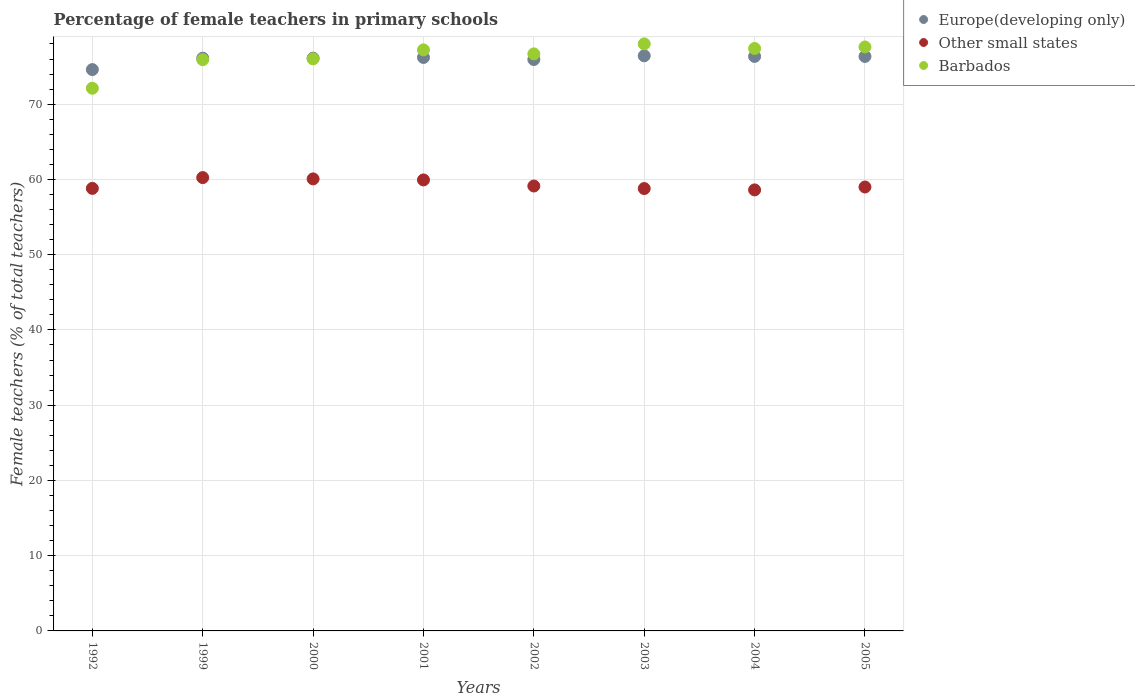What is the percentage of female teachers in Europe(developing only) in 2002?
Your answer should be compact. 75.94. Across all years, what is the maximum percentage of female teachers in Europe(developing only)?
Ensure brevity in your answer.  76.43. Across all years, what is the minimum percentage of female teachers in Other small states?
Your response must be concise. 58.61. In which year was the percentage of female teachers in Barbados maximum?
Your response must be concise. 2003. In which year was the percentage of female teachers in Barbados minimum?
Your response must be concise. 1992. What is the total percentage of female teachers in Europe(developing only) in the graph?
Provide a short and direct response. 608.1. What is the difference between the percentage of female teachers in Other small states in 2000 and that in 2003?
Your answer should be very brief. 1.28. What is the difference between the percentage of female teachers in Europe(developing only) in 1992 and the percentage of female teachers in Barbados in 2005?
Keep it short and to the point. -3.01. What is the average percentage of female teachers in Barbados per year?
Provide a short and direct response. 76.37. In the year 2003, what is the difference between the percentage of female teachers in Europe(developing only) and percentage of female teachers in Other small states?
Keep it short and to the point. 17.64. In how many years, is the percentage of female teachers in Other small states greater than 10 %?
Make the answer very short. 8. What is the ratio of the percentage of female teachers in Europe(developing only) in 2004 to that in 2005?
Your response must be concise. 1. Is the percentage of female teachers in Barbados in 2003 less than that in 2005?
Your response must be concise. No. Is the difference between the percentage of female teachers in Europe(developing only) in 2003 and 2004 greater than the difference between the percentage of female teachers in Other small states in 2003 and 2004?
Your response must be concise. No. What is the difference between the highest and the second highest percentage of female teachers in Barbados?
Ensure brevity in your answer.  0.41. What is the difference between the highest and the lowest percentage of female teachers in Europe(developing only)?
Provide a short and direct response. 1.83. Is the sum of the percentage of female teachers in Other small states in 1999 and 2001 greater than the maximum percentage of female teachers in Barbados across all years?
Give a very brief answer. Yes. Does the percentage of female teachers in Europe(developing only) monotonically increase over the years?
Keep it short and to the point. No. How many years are there in the graph?
Provide a succinct answer. 8. What is the difference between two consecutive major ticks on the Y-axis?
Your answer should be compact. 10. Are the values on the major ticks of Y-axis written in scientific E-notation?
Your answer should be very brief. No. Does the graph contain any zero values?
Ensure brevity in your answer.  No. Does the graph contain grids?
Offer a terse response. Yes. Where does the legend appear in the graph?
Offer a very short reply. Top right. How many legend labels are there?
Offer a terse response. 3. What is the title of the graph?
Keep it short and to the point. Percentage of female teachers in primary schools. Does "Bolivia" appear as one of the legend labels in the graph?
Provide a succinct answer. No. What is the label or title of the X-axis?
Provide a short and direct response. Years. What is the label or title of the Y-axis?
Provide a short and direct response. Female teachers (% of total teachers). What is the Female teachers (% of total teachers) of Europe(developing only) in 1992?
Your answer should be compact. 74.6. What is the Female teachers (% of total teachers) in Other small states in 1992?
Your response must be concise. 58.81. What is the Female teachers (% of total teachers) of Barbados in 1992?
Your answer should be very brief. 72.12. What is the Female teachers (% of total teachers) of Europe(developing only) in 1999?
Offer a very short reply. 76.11. What is the Female teachers (% of total teachers) in Other small states in 1999?
Make the answer very short. 60.24. What is the Female teachers (% of total teachers) of Barbados in 1999?
Your answer should be very brief. 75.91. What is the Female teachers (% of total teachers) in Europe(developing only) in 2000?
Give a very brief answer. 76.12. What is the Female teachers (% of total teachers) in Other small states in 2000?
Keep it short and to the point. 60.07. What is the Female teachers (% of total teachers) of Barbados in 2000?
Offer a terse response. 76.02. What is the Female teachers (% of total teachers) in Europe(developing only) in 2001?
Offer a terse response. 76.21. What is the Female teachers (% of total teachers) of Other small states in 2001?
Give a very brief answer. 59.93. What is the Female teachers (% of total teachers) in Barbados in 2001?
Provide a succinct answer. 77.22. What is the Female teachers (% of total teachers) of Europe(developing only) in 2002?
Ensure brevity in your answer.  75.94. What is the Female teachers (% of total teachers) in Other small states in 2002?
Provide a succinct answer. 59.12. What is the Female teachers (% of total teachers) of Barbados in 2002?
Give a very brief answer. 76.68. What is the Female teachers (% of total teachers) of Europe(developing only) in 2003?
Your answer should be compact. 76.43. What is the Female teachers (% of total teachers) of Other small states in 2003?
Your answer should be very brief. 58.79. What is the Female teachers (% of total teachers) of Barbados in 2003?
Keep it short and to the point. 78.01. What is the Female teachers (% of total teachers) in Europe(developing only) in 2004?
Your answer should be compact. 76.35. What is the Female teachers (% of total teachers) in Other small states in 2004?
Provide a succinct answer. 58.61. What is the Female teachers (% of total teachers) of Barbados in 2004?
Provide a succinct answer. 77.4. What is the Female teachers (% of total teachers) in Europe(developing only) in 2005?
Your answer should be compact. 76.34. What is the Female teachers (% of total teachers) of Other small states in 2005?
Your answer should be very brief. 58.99. What is the Female teachers (% of total teachers) of Barbados in 2005?
Make the answer very short. 77.6. Across all years, what is the maximum Female teachers (% of total teachers) of Europe(developing only)?
Provide a short and direct response. 76.43. Across all years, what is the maximum Female teachers (% of total teachers) in Other small states?
Make the answer very short. 60.24. Across all years, what is the maximum Female teachers (% of total teachers) in Barbados?
Offer a terse response. 78.01. Across all years, what is the minimum Female teachers (% of total teachers) of Europe(developing only)?
Make the answer very short. 74.6. Across all years, what is the minimum Female teachers (% of total teachers) of Other small states?
Provide a succinct answer. 58.61. Across all years, what is the minimum Female teachers (% of total teachers) in Barbados?
Your answer should be very brief. 72.12. What is the total Female teachers (% of total teachers) of Europe(developing only) in the graph?
Ensure brevity in your answer.  608.1. What is the total Female teachers (% of total teachers) of Other small states in the graph?
Ensure brevity in your answer.  474.57. What is the total Female teachers (% of total teachers) of Barbados in the graph?
Provide a short and direct response. 610.97. What is the difference between the Female teachers (% of total teachers) in Europe(developing only) in 1992 and that in 1999?
Give a very brief answer. -1.52. What is the difference between the Female teachers (% of total teachers) of Other small states in 1992 and that in 1999?
Provide a short and direct response. -1.44. What is the difference between the Female teachers (% of total teachers) in Barbados in 1992 and that in 1999?
Your answer should be compact. -3.8. What is the difference between the Female teachers (% of total teachers) of Europe(developing only) in 1992 and that in 2000?
Your answer should be very brief. -1.52. What is the difference between the Female teachers (% of total teachers) in Other small states in 1992 and that in 2000?
Offer a terse response. -1.26. What is the difference between the Female teachers (% of total teachers) of Barbados in 1992 and that in 2000?
Provide a short and direct response. -3.9. What is the difference between the Female teachers (% of total teachers) in Europe(developing only) in 1992 and that in 2001?
Your response must be concise. -1.61. What is the difference between the Female teachers (% of total teachers) of Other small states in 1992 and that in 2001?
Ensure brevity in your answer.  -1.12. What is the difference between the Female teachers (% of total teachers) in Barbados in 1992 and that in 2001?
Provide a short and direct response. -5.1. What is the difference between the Female teachers (% of total teachers) in Europe(developing only) in 1992 and that in 2002?
Give a very brief answer. -1.34. What is the difference between the Female teachers (% of total teachers) in Other small states in 1992 and that in 2002?
Ensure brevity in your answer.  -0.32. What is the difference between the Female teachers (% of total teachers) in Barbados in 1992 and that in 2002?
Provide a succinct answer. -4.56. What is the difference between the Female teachers (% of total teachers) in Europe(developing only) in 1992 and that in 2003?
Give a very brief answer. -1.83. What is the difference between the Female teachers (% of total teachers) in Other small states in 1992 and that in 2003?
Offer a very short reply. 0.02. What is the difference between the Female teachers (% of total teachers) of Barbados in 1992 and that in 2003?
Give a very brief answer. -5.9. What is the difference between the Female teachers (% of total teachers) in Europe(developing only) in 1992 and that in 2004?
Keep it short and to the point. -1.75. What is the difference between the Female teachers (% of total teachers) of Other small states in 1992 and that in 2004?
Your response must be concise. 0.2. What is the difference between the Female teachers (% of total teachers) in Barbados in 1992 and that in 2004?
Provide a short and direct response. -5.28. What is the difference between the Female teachers (% of total teachers) of Europe(developing only) in 1992 and that in 2005?
Offer a terse response. -1.75. What is the difference between the Female teachers (% of total teachers) of Other small states in 1992 and that in 2005?
Provide a short and direct response. -0.18. What is the difference between the Female teachers (% of total teachers) of Barbados in 1992 and that in 2005?
Provide a short and direct response. -5.49. What is the difference between the Female teachers (% of total teachers) of Europe(developing only) in 1999 and that in 2000?
Give a very brief answer. -0.01. What is the difference between the Female teachers (% of total teachers) in Other small states in 1999 and that in 2000?
Provide a succinct answer. 0.17. What is the difference between the Female teachers (% of total teachers) of Barbados in 1999 and that in 2000?
Give a very brief answer. -0.11. What is the difference between the Female teachers (% of total teachers) in Europe(developing only) in 1999 and that in 2001?
Provide a succinct answer. -0.1. What is the difference between the Female teachers (% of total teachers) in Other small states in 1999 and that in 2001?
Your answer should be very brief. 0.31. What is the difference between the Female teachers (% of total teachers) of Barbados in 1999 and that in 2001?
Provide a short and direct response. -1.3. What is the difference between the Female teachers (% of total teachers) of Europe(developing only) in 1999 and that in 2002?
Make the answer very short. 0.17. What is the difference between the Female teachers (% of total teachers) in Other small states in 1999 and that in 2002?
Provide a succinct answer. 1.12. What is the difference between the Female teachers (% of total teachers) of Barbados in 1999 and that in 2002?
Your response must be concise. -0.77. What is the difference between the Female teachers (% of total teachers) in Europe(developing only) in 1999 and that in 2003?
Your response must be concise. -0.32. What is the difference between the Female teachers (% of total teachers) of Other small states in 1999 and that in 2003?
Your answer should be very brief. 1.46. What is the difference between the Female teachers (% of total teachers) in Barbados in 1999 and that in 2003?
Your answer should be compact. -2.1. What is the difference between the Female teachers (% of total teachers) in Europe(developing only) in 1999 and that in 2004?
Give a very brief answer. -0.23. What is the difference between the Female teachers (% of total teachers) of Other small states in 1999 and that in 2004?
Your answer should be very brief. 1.64. What is the difference between the Female teachers (% of total teachers) in Barbados in 1999 and that in 2004?
Provide a succinct answer. -1.49. What is the difference between the Female teachers (% of total teachers) of Europe(developing only) in 1999 and that in 2005?
Keep it short and to the point. -0.23. What is the difference between the Female teachers (% of total teachers) in Other small states in 1999 and that in 2005?
Provide a succinct answer. 1.25. What is the difference between the Female teachers (% of total teachers) of Barbados in 1999 and that in 2005?
Make the answer very short. -1.69. What is the difference between the Female teachers (% of total teachers) in Europe(developing only) in 2000 and that in 2001?
Ensure brevity in your answer.  -0.09. What is the difference between the Female teachers (% of total teachers) of Other small states in 2000 and that in 2001?
Keep it short and to the point. 0.14. What is the difference between the Female teachers (% of total teachers) in Barbados in 2000 and that in 2001?
Ensure brevity in your answer.  -1.19. What is the difference between the Female teachers (% of total teachers) of Europe(developing only) in 2000 and that in 2002?
Make the answer very short. 0.18. What is the difference between the Female teachers (% of total teachers) of Other small states in 2000 and that in 2002?
Provide a succinct answer. 0.95. What is the difference between the Female teachers (% of total teachers) of Barbados in 2000 and that in 2002?
Provide a succinct answer. -0.66. What is the difference between the Female teachers (% of total teachers) in Europe(developing only) in 2000 and that in 2003?
Your answer should be very brief. -0.31. What is the difference between the Female teachers (% of total teachers) of Other small states in 2000 and that in 2003?
Keep it short and to the point. 1.28. What is the difference between the Female teachers (% of total teachers) of Barbados in 2000 and that in 2003?
Make the answer very short. -1.99. What is the difference between the Female teachers (% of total teachers) of Europe(developing only) in 2000 and that in 2004?
Your response must be concise. -0.23. What is the difference between the Female teachers (% of total teachers) of Other small states in 2000 and that in 2004?
Give a very brief answer. 1.46. What is the difference between the Female teachers (% of total teachers) of Barbados in 2000 and that in 2004?
Ensure brevity in your answer.  -1.38. What is the difference between the Female teachers (% of total teachers) in Europe(developing only) in 2000 and that in 2005?
Make the answer very short. -0.23. What is the difference between the Female teachers (% of total teachers) in Other small states in 2000 and that in 2005?
Your answer should be very brief. 1.08. What is the difference between the Female teachers (% of total teachers) of Barbados in 2000 and that in 2005?
Your answer should be very brief. -1.58. What is the difference between the Female teachers (% of total teachers) in Europe(developing only) in 2001 and that in 2002?
Ensure brevity in your answer.  0.27. What is the difference between the Female teachers (% of total teachers) of Other small states in 2001 and that in 2002?
Offer a terse response. 0.81. What is the difference between the Female teachers (% of total teachers) in Barbados in 2001 and that in 2002?
Offer a terse response. 0.53. What is the difference between the Female teachers (% of total teachers) in Europe(developing only) in 2001 and that in 2003?
Offer a terse response. -0.22. What is the difference between the Female teachers (% of total teachers) in Other small states in 2001 and that in 2003?
Keep it short and to the point. 1.15. What is the difference between the Female teachers (% of total teachers) of Barbados in 2001 and that in 2003?
Your answer should be compact. -0.8. What is the difference between the Female teachers (% of total teachers) in Europe(developing only) in 2001 and that in 2004?
Provide a succinct answer. -0.14. What is the difference between the Female teachers (% of total teachers) in Other small states in 2001 and that in 2004?
Give a very brief answer. 1.33. What is the difference between the Female teachers (% of total teachers) of Barbados in 2001 and that in 2004?
Keep it short and to the point. -0.19. What is the difference between the Female teachers (% of total teachers) of Europe(developing only) in 2001 and that in 2005?
Offer a very short reply. -0.14. What is the difference between the Female teachers (% of total teachers) in Other small states in 2001 and that in 2005?
Give a very brief answer. 0.94. What is the difference between the Female teachers (% of total teachers) of Barbados in 2001 and that in 2005?
Provide a succinct answer. -0.39. What is the difference between the Female teachers (% of total teachers) in Europe(developing only) in 2002 and that in 2003?
Make the answer very short. -0.49. What is the difference between the Female teachers (% of total teachers) in Other small states in 2002 and that in 2003?
Provide a succinct answer. 0.34. What is the difference between the Female teachers (% of total teachers) in Barbados in 2002 and that in 2003?
Keep it short and to the point. -1.33. What is the difference between the Female teachers (% of total teachers) in Europe(developing only) in 2002 and that in 2004?
Keep it short and to the point. -0.41. What is the difference between the Female teachers (% of total teachers) in Other small states in 2002 and that in 2004?
Provide a succinct answer. 0.52. What is the difference between the Female teachers (% of total teachers) in Barbados in 2002 and that in 2004?
Give a very brief answer. -0.72. What is the difference between the Female teachers (% of total teachers) of Europe(developing only) in 2002 and that in 2005?
Your answer should be compact. -0.41. What is the difference between the Female teachers (% of total teachers) in Other small states in 2002 and that in 2005?
Provide a short and direct response. 0.13. What is the difference between the Female teachers (% of total teachers) of Barbados in 2002 and that in 2005?
Your answer should be very brief. -0.92. What is the difference between the Female teachers (% of total teachers) in Europe(developing only) in 2003 and that in 2004?
Ensure brevity in your answer.  0.09. What is the difference between the Female teachers (% of total teachers) in Other small states in 2003 and that in 2004?
Your response must be concise. 0.18. What is the difference between the Female teachers (% of total teachers) in Barbados in 2003 and that in 2004?
Offer a terse response. 0.61. What is the difference between the Female teachers (% of total teachers) of Europe(developing only) in 2003 and that in 2005?
Keep it short and to the point. 0.09. What is the difference between the Female teachers (% of total teachers) in Other small states in 2003 and that in 2005?
Provide a succinct answer. -0.2. What is the difference between the Female teachers (% of total teachers) of Barbados in 2003 and that in 2005?
Your answer should be very brief. 0.41. What is the difference between the Female teachers (% of total teachers) of Europe(developing only) in 2004 and that in 2005?
Offer a terse response. 0. What is the difference between the Female teachers (% of total teachers) in Other small states in 2004 and that in 2005?
Your response must be concise. -0.39. What is the difference between the Female teachers (% of total teachers) of Barbados in 2004 and that in 2005?
Provide a short and direct response. -0.2. What is the difference between the Female teachers (% of total teachers) of Europe(developing only) in 1992 and the Female teachers (% of total teachers) of Other small states in 1999?
Your response must be concise. 14.35. What is the difference between the Female teachers (% of total teachers) in Europe(developing only) in 1992 and the Female teachers (% of total teachers) in Barbados in 1999?
Your response must be concise. -1.32. What is the difference between the Female teachers (% of total teachers) in Other small states in 1992 and the Female teachers (% of total teachers) in Barbados in 1999?
Provide a short and direct response. -17.1. What is the difference between the Female teachers (% of total teachers) in Europe(developing only) in 1992 and the Female teachers (% of total teachers) in Other small states in 2000?
Your answer should be very brief. 14.53. What is the difference between the Female teachers (% of total teachers) of Europe(developing only) in 1992 and the Female teachers (% of total teachers) of Barbados in 2000?
Give a very brief answer. -1.43. What is the difference between the Female teachers (% of total teachers) of Other small states in 1992 and the Female teachers (% of total teachers) of Barbados in 2000?
Make the answer very short. -17.21. What is the difference between the Female teachers (% of total teachers) in Europe(developing only) in 1992 and the Female teachers (% of total teachers) in Other small states in 2001?
Ensure brevity in your answer.  14.66. What is the difference between the Female teachers (% of total teachers) of Europe(developing only) in 1992 and the Female teachers (% of total teachers) of Barbados in 2001?
Make the answer very short. -2.62. What is the difference between the Female teachers (% of total teachers) in Other small states in 1992 and the Female teachers (% of total teachers) in Barbados in 2001?
Your response must be concise. -18.41. What is the difference between the Female teachers (% of total teachers) of Europe(developing only) in 1992 and the Female teachers (% of total teachers) of Other small states in 2002?
Make the answer very short. 15.47. What is the difference between the Female teachers (% of total teachers) of Europe(developing only) in 1992 and the Female teachers (% of total teachers) of Barbados in 2002?
Make the answer very short. -2.09. What is the difference between the Female teachers (% of total teachers) of Other small states in 1992 and the Female teachers (% of total teachers) of Barbados in 2002?
Ensure brevity in your answer.  -17.87. What is the difference between the Female teachers (% of total teachers) of Europe(developing only) in 1992 and the Female teachers (% of total teachers) of Other small states in 2003?
Keep it short and to the point. 15.81. What is the difference between the Female teachers (% of total teachers) of Europe(developing only) in 1992 and the Female teachers (% of total teachers) of Barbados in 2003?
Keep it short and to the point. -3.42. What is the difference between the Female teachers (% of total teachers) of Other small states in 1992 and the Female teachers (% of total teachers) of Barbados in 2003?
Provide a succinct answer. -19.2. What is the difference between the Female teachers (% of total teachers) in Europe(developing only) in 1992 and the Female teachers (% of total teachers) in Other small states in 2004?
Offer a very short reply. 15.99. What is the difference between the Female teachers (% of total teachers) in Europe(developing only) in 1992 and the Female teachers (% of total teachers) in Barbados in 2004?
Ensure brevity in your answer.  -2.8. What is the difference between the Female teachers (% of total teachers) in Other small states in 1992 and the Female teachers (% of total teachers) in Barbados in 2004?
Provide a short and direct response. -18.59. What is the difference between the Female teachers (% of total teachers) of Europe(developing only) in 1992 and the Female teachers (% of total teachers) of Other small states in 2005?
Ensure brevity in your answer.  15.6. What is the difference between the Female teachers (% of total teachers) in Europe(developing only) in 1992 and the Female teachers (% of total teachers) in Barbados in 2005?
Provide a short and direct response. -3.01. What is the difference between the Female teachers (% of total teachers) in Other small states in 1992 and the Female teachers (% of total teachers) in Barbados in 2005?
Give a very brief answer. -18.79. What is the difference between the Female teachers (% of total teachers) in Europe(developing only) in 1999 and the Female teachers (% of total teachers) in Other small states in 2000?
Your answer should be compact. 16.04. What is the difference between the Female teachers (% of total teachers) in Europe(developing only) in 1999 and the Female teachers (% of total teachers) in Barbados in 2000?
Your answer should be very brief. 0.09. What is the difference between the Female teachers (% of total teachers) in Other small states in 1999 and the Female teachers (% of total teachers) in Barbados in 2000?
Your answer should be compact. -15.78. What is the difference between the Female teachers (% of total teachers) of Europe(developing only) in 1999 and the Female teachers (% of total teachers) of Other small states in 2001?
Give a very brief answer. 16.18. What is the difference between the Female teachers (% of total teachers) in Europe(developing only) in 1999 and the Female teachers (% of total teachers) in Barbados in 2001?
Keep it short and to the point. -1.1. What is the difference between the Female teachers (% of total teachers) of Other small states in 1999 and the Female teachers (% of total teachers) of Barbados in 2001?
Provide a succinct answer. -16.97. What is the difference between the Female teachers (% of total teachers) in Europe(developing only) in 1999 and the Female teachers (% of total teachers) in Other small states in 2002?
Provide a succinct answer. 16.99. What is the difference between the Female teachers (% of total teachers) of Europe(developing only) in 1999 and the Female teachers (% of total teachers) of Barbados in 2002?
Ensure brevity in your answer.  -0.57. What is the difference between the Female teachers (% of total teachers) of Other small states in 1999 and the Female teachers (% of total teachers) of Barbados in 2002?
Offer a very short reply. -16.44. What is the difference between the Female teachers (% of total teachers) in Europe(developing only) in 1999 and the Female teachers (% of total teachers) in Other small states in 2003?
Provide a short and direct response. 17.32. What is the difference between the Female teachers (% of total teachers) in Europe(developing only) in 1999 and the Female teachers (% of total teachers) in Barbados in 2003?
Ensure brevity in your answer.  -1.9. What is the difference between the Female teachers (% of total teachers) in Other small states in 1999 and the Female teachers (% of total teachers) in Barbados in 2003?
Ensure brevity in your answer.  -17.77. What is the difference between the Female teachers (% of total teachers) in Europe(developing only) in 1999 and the Female teachers (% of total teachers) in Other small states in 2004?
Offer a terse response. 17.5. What is the difference between the Female teachers (% of total teachers) of Europe(developing only) in 1999 and the Female teachers (% of total teachers) of Barbados in 2004?
Give a very brief answer. -1.29. What is the difference between the Female teachers (% of total teachers) of Other small states in 1999 and the Female teachers (% of total teachers) of Barbados in 2004?
Your answer should be compact. -17.16. What is the difference between the Female teachers (% of total teachers) in Europe(developing only) in 1999 and the Female teachers (% of total teachers) in Other small states in 2005?
Offer a terse response. 17.12. What is the difference between the Female teachers (% of total teachers) of Europe(developing only) in 1999 and the Female teachers (% of total teachers) of Barbados in 2005?
Offer a very short reply. -1.49. What is the difference between the Female teachers (% of total teachers) of Other small states in 1999 and the Female teachers (% of total teachers) of Barbados in 2005?
Offer a very short reply. -17.36. What is the difference between the Female teachers (% of total teachers) in Europe(developing only) in 2000 and the Female teachers (% of total teachers) in Other small states in 2001?
Your answer should be very brief. 16.18. What is the difference between the Female teachers (% of total teachers) in Europe(developing only) in 2000 and the Female teachers (% of total teachers) in Barbados in 2001?
Give a very brief answer. -1.1. What is the difference between the Female teachers (% of total teachers) in Other small states in 2000 and the Female teachers (% of total teachers) in Barbados in 2001?
Provide a short and direct response. -17.14. What is the difference between the Female teachers (% of total teachers) of Europe(developing only) in 2000 and the Female teachers (% of total teachers) of Other small states in 2002?
Your response must be concise. 16.99. What is the difference between the Female teachers (% of total teachers) in Europe(developing only) in 2000 and the Female teachers (% of total teachers) in Barbados in 2002?
Give a very brief answer. -0.56. What is the difference between the Female teachers (% of total teachers) of Other small states in 2000 and the Female teachers (% of total teachers) of Barbados in 2002?
Your answer should be compact. -16.61. What is the difference between the Female teachers (% of total teachers) in Europe(developing only) in 2000 and the Female teachers (% of total teachers) in Other small states in 2003?
Your response must be concise. 17.33. What is the difference between the Female teachers (% of total teachers) in Europe(developing only) in 2000 and the Female teachers (% of total teachers) in Barbados in 2003?
Make the answer very short. -1.9. What is the difference between the Female teachers (% of total teachers) of Other small states in 2000 and the Female teachers (% of total teachers) of Barbados in 2003?
Offer a terse response. -17.94. What is the difference between the Female teachers (% of total teachers) in Europe(developing only) in 2000 and the Female teachers (% of total teachers) in Other small states in 2004?
Your answer should be very brief. 17.51. What is the difference between the Female teachers (% of total teachers) in Europe(developing only) in 2000 and the Female teachers (% of total teachers) in Barbados in 2004?
Your response must be concise. -1.28. What is the difference between the Female teachers (% of total teachers) in Other small states in 2000 and the Female teachers (% of total teachers) in Barbados in 2004?
Keep it short and to the point. -17.33. What is the difference between the Female teachers (% of total teachers) of Europe(developing only) in 2000 and the Female teachers (% of total teachers) of Other small states in 2005?
Provide a succinct answer. 17.13. What is the difference between the Female teachers (% of total teachers) of Europe(developing only) in 2000 and the Female teachers (% of total teachers) of Barbados in 2005?
Make the answer very short. -1.49. What is the difference between the Female teachers (% of total teachers) in Other small states in 2000 and the Female teachers (% of total teachers) in Barbados in 2005?
Your answer should be compact. -17.53. What is the difference between the Female teachers (% of total teachers) of Europe(developing only) in 2001 and the Female teachers (% of total teachers) of Other small states in 2002?
Keep it short and to the point. 17.08. What is the difference between the Female teachers (% of total teachers) of Europe(developing only) in 2001 and the Female teachers (% of total teachers) of Barbados in 2002?
Ensure brevity in your answer.  -0.47. What is the difference between the Female teachers (% of total teachers) of Other small states in 2001 and the Female teachers (% of total teachers) of Barbados in 2002?
Ensure brevity in your answer.  -16.75. What is the difference between the Female teachers (% of total teachers) in Europe(developing only) in 2001 and the Female teachers (% of total teachers) in Other small states in 2003?
Keep it short and to the point. 17.42. What is the difference between the Female teachers (% of total teachers) of Europe(developing only) in 2001 and the Female teachers (% of total teachers) of Barbados in 2003?
Offer a very short reply. -1.81. What is the difference between the Female teachers (% of total teachers) of Other small states in 2001 and the Female teachers (% of total teachers) of Barbados in 2003?
Offer a terse response. -18.08. What is the difference between the Female teachers (% of total teachers) of Europe(developing only) in 2001 and the Female teachers (% of total teachers) of Other small states in 2004?
Give a very brief answer. 17.6. What is the difference between the Female teachers (% of total teachers) of Europe(developing only) in 2001 and the Female teachers (% of total teachers) of Barbados in 2004?
Ensure brevity in your answer.  -1.19. What is the difference between the Female teachers (% of total teachers) in Other small states in 2001 and the Female teachers (% of total teachers) in Barbados in 2004?
Make the answer very short. -17.47. What is the difference between the Female teachers (% of total teachers) of Europe(developing only) in 2001 and the Female teachers (% of total teachers) of Other small states in 2005?
Provide a succinct answer. 17.22. What is the difference between the Female teachers (% of total teachers) of Europe(developing only) in 2001 and the Female teachers (% of total teachers) of Barbados in 2005?
Your response must be concise. -1.4. What is the difference between the Female teachers (% of total teachers) of Other small states in 2001 and the Female teachers (% of total teachers) of Barbados in 2005?
Your answer should be compact. -17.67. What is the difference between the Female teachers (% of total teachers) of Europe(developing only) in 2002 and the Female teachers (% of total teachers) of Other small states in 2003?
Make the answer very short. 17.15. What is the difference between the Female teachers (% of total teachers) of Europe(developing only) in 2002 and the Female teachers (% of total teachers) of Barbados in 2003?
Your answer should be very brief. -2.07. What is the difference between the Female teachers (% of total teachers) in Other small states in 2002 and the Female teachers (% of total teachers) in Barbados in 2003?
Offer a very short reply. -18.89. What is the difference between the Female teachers (% of total teachers) of Europe(developing only) in 2002 and the Female teachers (% of total teachers) of Other small states in 2004?
Your response must be concise. 17.33. What is the difference between the Female teachers (% of total teachers) of Europe(developing only) in 2002 and the Female teachers (% of total teachers) of Barbados in 2004?
Offer a very short reply. -1.46. What is the difference between the Female teachers (% of total teachers) in Other small states in 2002 and the Female teachers (% of total teachers) in Barbados in 2004?
Provide a short and direct response. -18.28. What is the difference between the Female teachers (% of total teachers) in Europe(developing only) in 2002 and the Female teachers (% of total teachers) in Other small states in 2005?
Provide a succinct answer. 16.95. What is the difference between the Female teachers (% of total teachers) of Europe(developing only) in 2002 and the Female teachers (% of total teachers) of Barbados in 2005?
Provide a succinct answer. -1.66. What is the difference between the Female teachers (% of total teachers) of Other small states in 2002 and the Female teachers (% of total teachers) of Barbados in 2005?
Your answer should be compact. -18.48. What is the difference between the Female teachers (% of total teachers) in Europe(developing only) in 2003 and the Female teachers (% of total teachers) in Other small states in 2004?
Offer a terse response. 17.82. What is the difference between the Female teachers (% of total teachers) in Europe(developing only) in 2003 and the Female teachers (% of total teachers) in Barbados in 2004?
Provide a succinct answer. -0.97. What is the difference between the Female teachers (% of total teachers) of Other small states in 2003 and the Female teachers (% of total teachers) of Barbados in 2004?
Your answer should be compact. -18.61. What is the difference between the Female teachers (% of total teachers) of Europe(developing only) in 2003 and the Female teachers (% of total teachers) of Other small states in 2005?
Your response must be concise. 17.44. What is the difference between the Female teachers (% of total teachers) in Europe(developing only) in 2003 and the Female teachers (% of total teachers) in Barbados in 2005?
Offer a very short reply. -1.17. What is the difference between the Female teachers (% of total teachers) of Other small states in 2003 and the Female teachers (% of total teachers) of Barbados in 2005?
Give a very brief answer. -18.82. What is the difference between the Female teachers (% of total teachers) in Europe(developing only) in 2004 and the Female teachers (% of total teachers) in Other small states in 2005?
Ensure brevity in your answer.  17.35. What is the difference between the Female teachers (% of total teachers) of Europe(developing only) in 2004 and the Female teachers (% of total teachers) of Barbados in 2005?
Offer a very short reply. -1.26. What is the difference between the Female teachers (% of total teachers) in Other small states in 2004 and the Female teachers (% of total teachers) in Barbados in 2005?
Provide a short and direct response. -19. What is the average Female teachers (% of total teachers) in Europe(developing only) per year?
Give a very brief answer. 76.01. What is the average Female teachers (% of total teachers) in Other small states per year?
Keep it short and to the point. 59.32. What is the average Female teachers (% of total teachers) in Barbados per year?
Your answer should be very brief. 76.37. In the year 1992, what is the difference between the Female teachers (% of total teachers) of Europe(developing only) and Female teachers (% of total teachers) of Other small states?
Your answer should be compact. 15.79. In the year 1992, what is the difference between the Female teachers (% of total teachers) in Europe(developing only) and Female teachers (% of total teachers) in Barbados?
Make the answer very short. 2.48. In the year 1992, what is the difference between the Female teachers (% of total teachers) in Other small states and Female teachers (% of total teachers) in Barbados?
Your response must be concise. -13.31. In the year 1999, what is the difference between the Female teachers (% of total teachers) in Europe(developing only) and Female teachers (% of total teachers) in Other small states?
Provide a short and direct response. 15.87. In the year 1999, what is the difference between the Female teachers (% of total teachers) in Europe(developing only) and Female teachers (% of total teachers) in Barbados?
Provide a short and direct response. 0.2. In the year 1999, what is the difference between the Female teachers (% of total teachers) in Other small states and Female teachers (% of total teachers) in Barbados?
Your response must be concise. -15.67. In the year 2000, what is the difference between the Female teachers (% of total teachers) in Europe(developing only) and Female teachers (% of total teachers) in Other small states?
Offer a very short reply. 16.05. In the year 2000, what is the difference between the Female teachers (% of total teachers) of Europe(developing only) and Female teachers (% of total teachers) of Barbados?
Your response must be concise. 0.09. In the year 2000, what is the difference between the Female teachers (% of total teachers) of Other small states and Female teachers (% of total teachers) of Barbados?
Ensure brevity in your answer.  -15.95. In the year 2001, what is the difference between the Female teachers (% of total teachers) in Europe(developing only) and Female teachers (% of total teachers) in Other small states?
Make the answer very short. 16.27. In the year 2001, what is the difference between the Female teachers (% of total teachers) in Europe(developing only) and Female teachers (% of total teachers) in Barbados?
Offer a terse response. -1.01. In the year 2001, what is the difference between the Female teachers (% of total teachers) of Other small states and Female teachers (% of total teachers) of Barbados?
Offer a very short reply. -17.28. In the year 2002, what is the difference between the Female teachers (% of total teachers) in Europe(developing only) and Female teachers (% of total teachers) in Other small states?
Your response must be concise. 16.81. In the year 2002, what is the difference between the Female teachers (% of total teachers) in Europe(developing only) and Female teachers (% of total teachers) in Barbados?
Give a very brief answer. -0.74. In the year 2002, what is the difference between the Female teachers (% of total teachers) of Other small states and Female teachers (% of total teachers) of Barbados?
Ensure brevity in your answer.  -17.56. In the year 2003, what is the difference between the Female teachers (% of total teachers) of Europe(developing only) and Female teachers (% of total teachers) of Other small states?
Your answer should be compact. 17.64. In the year 2003, what is the difference between the Female teachers (% of total teachers) of Europe(developing only) and Female teachers (% of total teachers) of Barbados?
Your answer should be very brief. -1.58. In the year 2003, what is the difference between the Female teachers (% of total teachers) in Other small states and Female teachers (% of total teachers) in Barbados?
Offer a very short reply. -19.23. In the year 2004, what is the difference between the Female teachers (% of total teachers) of Europe(developing only) and Female teachers (% of total teachers) of Other small states?
Offer a terse response. 17.74. In the year 2004, what is the difference between the Female teachers (% of total teachers) of Europe(developing only) and Female teachers (% of total teachers) of Barbados?
Provide a succinct answer. -1.05. In the year 2004, what is the difference between the Female teachers (% of total teachers) in Other small states and Female teachers (% of total teachers) in Barbados?
Provide a short and direct response. -18.79. In the year 2005, what is the difference between the Female teachers (% of total teachers) of Europe(developing only) and Female teachers (% of total teachers) of Other small states?
Offer a very short reply. 17.35. In the year 2005, what is the difference between the Female teachers (% of total teachers) in Europe(developing only) and Female teachers (% of total teachers) in Barbados?
Offer a very short reply. -1.26. In the year 2005, what is the difference between the Female teachers (% of total teachers) in Other small states and Female teachers (% of total teachers) in Barbados?
Offer a very short reply. -18.61. What is the ratio of the Female teachers (% of total teachers) of Europe(developing only) in 1992 to that in 1999?
Ensure brevity in your answer.  0.98. What is the ratio of the Female teachers (% of total teachers) of Other small states in 1992 to that in 1999?
Provide a short and direct response. 0.98. What is the ratio of the Female teachers (% of total teachers) of Europe(developing only) in 1992 to that in 2000?
Your response must be concise. 0.98. What is the ratio of the Female teachers (% of total teachers) of Barbados in 1992 to that in 2000?
Keep it short and to the point. 0.95. What is the ratio of the Female teachers (% of total teachers) in Europe(developing only) in 1992 to that in 2001?
Provide a succinct answer. 0.98. What is the ratio of the Female teachers (% of total teachers) in Other small states in 1992 to that in 2001?
Offer a very short reply. 0.98. What is the ratio of the Female teachers (% of total teachers) in Barbados in 1992 to that in 2001?
Give a very brief answer. 0.93. What is the ratio of the Female teachers (% of total teachers) in Europe(developing only) in 1992 to that in 2002?
Your answer should be very brief. 0.98. What is the ratio of the Female teachers (% of total teachers) in Barbados in 1992 to that in 2002?
Provide a succinct answer. 0.94. What is the ratio of the Female teachers (% of total teachers) in Other small states in 1992 to that in 2003?
Your response must be concise. 1. What is the ratio of the Female teachers (% of total teachers) in Barbados in 1992 to that in 2003?
Provide a succinct answer. 0.92. What is the ratio of the Female teachers (% of total teachers) of Europe(developing only) in 1992 to that in 2004?
Provide a short and direct response. 0.98. What is the ratio of the Female teachers (% of total teachers) of Barbados in 1992 to that in 2004?
Offer a terse response. 0.93. What is the ratio of the Female teachers (% of total teachers) of Europe(developing only) in 1992 to that in 2005?
Your answer should be compact. 0.98. What is the ratio of the Female teachers (% of total teachers) of Barbados in 1992 to that in 2005?
Your answer should be very brief. 0.93. What is the ratio of the Female teachers (% of total teachers) in Europe(developing only) in 1999 to that in 2000?
Your answer should be very brief. 1. What is the ratio of the Female teachers (% of total teachers) in Other small states in 1999 to that in 2000?
Ensure brevity in your answer.  1. What is the ratio of the Female teachers (% of total teachers) in Barbados in 1999 to that in 2000?
Your answer should be very brief. 1. What is the ratio of the Female teachers (% of total teachers) of Other small states in 1999 to that in 2001?
Offer a very short reply. 1.01. What is the ratio of the Female teachers (% of total teachers) in Barbados in 1999 to that in 2001?
Your response must be concise. 0.98. What is the ratio of the Female teachers (% of total teachers) in Europe(developing only) in 1999 to that in 2002?
Offer a terse response. 1. What is the ratio of the Female teachers (% of total teachers) in Other small states in 1999 to that in 2002?
Your answer should be compact. 1.02. What is the ratio of the Female teachers (% of total teachers) in Europe(developing only) in 1999 to that in 2003?
Make the answer very short. 1. What is the ratio of the Female teachers (% of total teachers) in Other small states in 1999 to that in 2003?
Offer a terse response. 1.02. What is the ratio of the Female teachers (% of total teachers) of Barbados in 1999 to that in 2003?
Your answer should be very brief. 0.97. What is the ratio of the Female teachers (% of total teachers) in Europe(developing only) in 1999 to that in 2004?
Provide a short and direct response. 1. What is the ratio of the Female teachers (% of total teachers) in Other small states in 1999 to that in 2004?
Give a very brief answer. 1.03. What is the ratio of the Female teachers (% of total teachers) in Barbados in 1999 to that in 2004?
Give a very brief answer. 0.98. What is the ratio of the Female teachers (% of total teachers) of Europe(developing only) in 1999 to that in 2005?
Offer a terse response. 1. What is the ratio of the Female teachers (% of total teachers) of Other small states in 1999 to that in 2005?
Keep it short and to the point. 1.02. What is the ratio of the Female teachers (% of total teachers) in Barbados in 1999 to that in 2005?
Your answer should be very brief. 0.98. What is the ratio of the Female teachers (% of total teachers) in Other small states in 2000 to that in 2001?
Offer a terse response. 1. What is the ratio of the Female teachers (% of total teachers) in Barbados in 2000 to that in 2001?
Keep it short and to the point. 0.98. What is the ratio of the Female teachers (% of total teachers) in Other small states in 2000 to that in 2002?
Give a very brief answer. 1.02. What is the ratio of the Female teachers (% of total teachers) in Barbados in 2000 to that in 2002?
Ensure brevity in your answer.  0.99. What is the ratio of the Female teachers (% of total teachers) of Europe(developing only) in 2000 to that in 2003?
Your answer should be very brief. 1. What is the ratio of the Female teachers (% of total teachers) in Other small states in 2000 to that in 2003?
Your answer should be very brief. 1.02. What is the ratio of the Female teachers (% of total teachers) in Barbados in 2000 to that in 2003?
Ensure brevity in your answer.  0.97. What is the ratio of the Female teachers (% of total teachers) of Europe(developing only) in 2000 to that in 2004?
Your answer should be very brief. 1. What is the ratio of the Female teachers (% of total teachers) of Barbados in 2000 to that in 2004?
Give a very brief answer. 0.98. What is the ratio of the Female teachers (% of total teachers) in Europe(developing only) in 2000 to that in 2005?
Keep it short and to the point. 1. What is the ratio of the Female teachers (% of total teachers) of Other small states in 2000 to that in 2005?
Your answer should be compact. 1.02. What is the ratio of the Female teachers (% of total teachers) in Barbados in 2000 to that in 2005?
Keep it short and to the point. 0.98. What is the ratio of the Female teachers (% of total teachers) in Other small states in 2001 to that in 2002?
Your answer should be very brief. 1.01. What is the ratio of the Female teachers (% of total teachers) of Barbados in 2001 to that in 2002?
Offer a terse response. 1.01. What is the ratio of the Female teachers (% of total teachers) in Other small states in 2001 to that in 2003?
Offer a terse response. 1.02. What is the ratio of the Female teachers (% of total teachers) in Other small states in 2001 to that in 2004?
Your answer should be very brief. 1.02. What is the ratio of the Female teachers (% of total teachers) of Barbados in 2001 to that in 2004?
Your answer should be very brief. 1. What is the ratio of the Female teachers (% of total teachers) in Europe(developing only) in 2001 to that in 2005?
Provide a short and direct response. 1. What is the ratio of the Female teachers (% of total teachers) of Other small states in 2002 to that in 2003?
Provide a succinct answer. 1.01. What is the ratio of the Female teachers (% of total teachers) of Barbados in 2002 to that in 2003?
Make the answer very short. 0.98. What is the ratio of the Female teachers (% of total teachers) of Other small states in 2002 to that in 2004?
Offer a very short reply. 1.01. What is the ratio of the Female teachers (% of total teachers) in Barbados in 2002 to that in 2004?
Give a very brief answer. 0.99. What is the ratio of the Female teachers (% of total teachers) of Other small states in 2002 to that in 2005?
Provide a short and direct response. 1. What is the ratio of the Female teachers (% of total teachers) of Barbados in 2002 to that in 2005?
Make the answer very short. 0.99. What is the ratio of the Female teachers (% of total teachers) of Europe(developing only) in 2003 to that in 2004?
Offer a very short reply. 1. What is the ratio of the Female teachers (% of total teachers) of Barbados in 2003 to that in 2004?
Your answer should be very brief. 1.01. What is the ratio of the Female teachers (% of total teachers) in Other small states in 2003 to that in 2005?
Your response must be concise. 1. What is the ratio of the Female teachers (% of total teachers) in Europe(developing only) in 2004 to that in 2005?
Your answer should be compact. 1. What is the ratio of the Female teachers (% of total teachers) in Other small states in 2004 to that in 2005?
Your response must be concise. 0.99. What is the difference between the highest and the second highest Female teachers (% of total teachers) in Europe(developing only)?
Your answer should be compact. 0.09. What is the difference between the highest and the second highest Female teachers (% of total teachers) of Other small states?
Provide a succinct answer. 0.17. What is the difference between the highest and the second highest Female teachers (% of total teachers) of Barbados?
Provide a short and direct response. 0.41. What is the difference between the highest and the lowest Female teachers (% of total teachers) in Europe(developing only)?
Provide a succinct answer. 1.83. What is the difference between the highest and the lowest Female teachers (% of total teachers) in Other small states?
Your response must be concise. 1.64. What is the difference between the highest and the lowest Female teachers (% of total teachers) of Barbados?
Give a very brief answer. 5.9. 